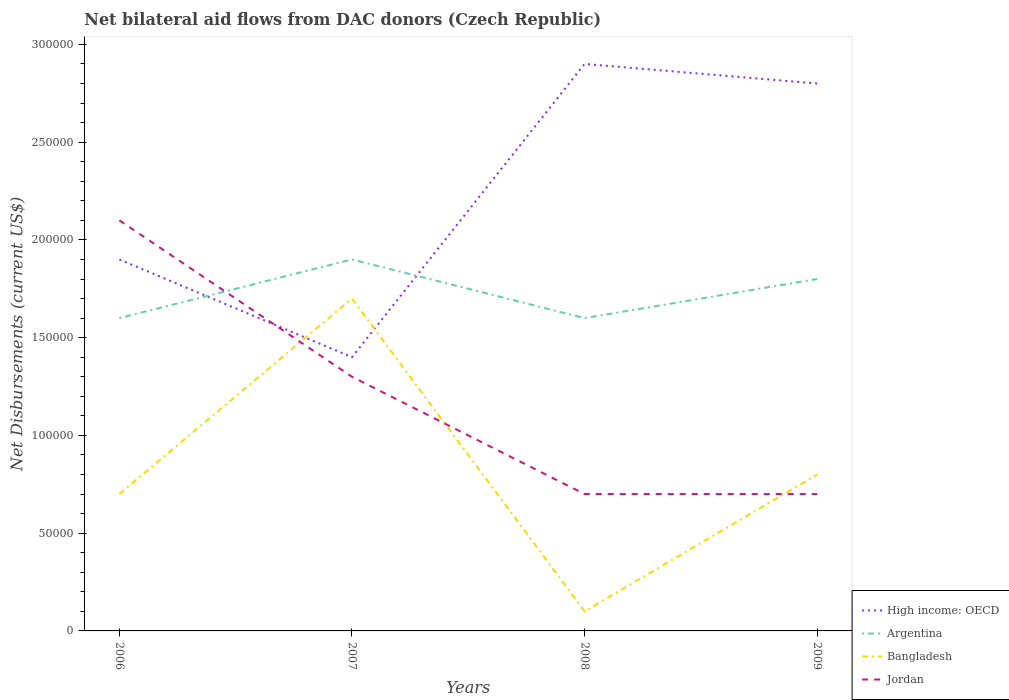How many different coloured lines are there?
Make the answer very short. 4. Does the line corresponding to Jordan intersect with the line corresponding to Bangladesh?
Provide a succinct answer. Yes. Across all years, what is the maximum net bilateral aid flows in Bangladesh?
Provide a short and direct response. 10000. In which year was the net bilateral aid flows in Bangladesh maximum?
Your answer should be compact. 2008. What is the total net bilateral aid flows in Argentina in the graph?
Your answer should be very brief. -2.00e+04. What is the difference between the highest and the second highest net bilateral aid flows in Jordan?
Offer a very short reply. 1.40e+05. What is the difference between the highest and the lowest net bilateral aid flows in Argentina?
Offer a very short reply. 2. Is the net bilateral aid flows in Argentina strictly greater than the net bilateral aid flows in High income: OECD over the years?
Provide a succinct answer. No. How many lines are there?
Give a very brief answer. 4. How many years are there in the graph?
Provide a short and direct response. 4. Are the values on the major ticks of Y-axis written in scientific E-notation?
Ensure brevity in your answer.  No. Where does the legend appear in the graph?
Offer a very short reply. Bottom right. How are the legend labels stacked?
Make the answer very short. Vertical. What is the title of the graph?
Provide a succinct answer. Net bilateral aid flows from DAC donors (Czech Republic). What is the label or title of the Y-axis?
Make the answer very short. Net Disbursements (current US$). What is the Net Disbursements (current US$) in Bangladesh in 2006?
Ensure brevity in your answer.  7.00e+04. What is the Net Disbursements (current US$) of Argentina in 2007?
Your answer should be very brief. 1.90e+05. What is the Net Disbursements (current US$) in Jordan in 2007?
Your response must be concise. 1.30e+05. What is the Net Disbursements (current US$) in High income: OECD in 2008?
Provide a short and direct response. 2.90e+05. What is the Net Disbursements (current US$) of Jordan in 2008?
Provide a succinct answer. 7.00e+04. What is the Net Disbursements (current US$) in High income: OECD in 2009?
Provide a short and direct response. 2.80e+05. What is the Net Disbursements (current US$) in Argentina in 2009?
Your response must be concise. 1.80e+05. What is the Net Disbursements (current US$) in Bangladesh in 2009?
Offer a terse response. 8.00e+04. Across all years, what is the maximum Net Disbursements (current US$) of High income: OECD?
Offer a very short reply. 2.90e+05. Across all years, what is the maximum Net Disbursements (current US$) of Argentina?
Give a very brief answer. 1.90e+05. Across all years, what is the maximum Net Disbursements (current US$) in Jordan?
Provide a short and direct response. 2.10e+05. Across all years, what is the minimum Net Disbursements (current US$) of High income: OECD?
Your response must be concise. 1.40e+05. What is the total Net Disbursements (current US$) of Argentina in the graph?
Give a very brief answer. 6.90e+05. What is the difference between the Net Disbursements (current US$) of High income: OECD in 2006 and that in 2007?
Provide a short and direct response. 5.00e+04. What is the difference between the Net Disbursements (current US$) of Argentina in 2006 and that in 2007?
Ensure brevity in your answer.  -3.00e+04. What is the difference between the Net Disbursements (current US$) of Jordan in 2006 and that in 2007?
Keep it short and to the point. 8.00e+04. What is the difference between the Net Disbursements (current US$) of Argentina in 2006 and that in 2008?
Your response must be concise. 0. What is the difference between the Net Disbursements (current US$) in Bangladesh in 2006 and that in 2008?
Give a very brief answer. 6.00e+04. What is the difference between the Net Disbursements (current US$) of Jordan in 2006 and that in 2008?
Offer a very short reply. 1.40e+05. What is the difference between the Net Disbursements (current US$) of Argentina in 2006 and that in 2009?
Offer a very short reply. -2.00e+04. What is the difference between the Net Disbursements (current US$) in Bangladesh in 2006 and that in 2009?
Provide a short and direct response. -10000. What is the difference between the Net Disbursements (current US$) of Jordan in 2006 and that in 2009?
Offer a terse response. 1.40e+05. What is the difference between the Net Disbursements (current US$) of Bangladesh in 2007 and that in 2008?
Give a very brief answer. 1.60e+05. What is the difference between the Net Disbursements (current US$) of Argentina in 2007 and that in 2009?
Your response must be concise. 10000. What is the difference between the Net Disbursements (current US$) in Bangladesh in 2007 and that in 2009?
Make the answer very short. 9.00e+04. What is the difference between the Net Disbursements (current US$) in Jordan in 2007 and that in 2009?
Your answer should be compact. 6.00e+04. What is the difference between the Net Disbursements (current US$) of High income: OECD in 2008 and that in 2009?
Make the answer very short. 10000. What is the difference between the Net Disbursements (current US$) in Argentina in 2008 and that in 2009?
Provide a succinct answer. -2.00e+04. What is the difference between the Net Disbursements (current US$) of Bangladesh in 2008 and that in 2009?
Ensure brevity in your answer.  -7.00e+04. What is the difference between the Net Disbursements (current US$) of High income: OECD in 2006 and the Net Disbursements (current US$) of Bangladesh in 2007?
Your answer should be very brief. 2.00e+04. What is the difference between the Net Disbursements (current US$) in High income: OECD in 2006 and the Net Disbursements (current US$) in Jordan in 2007?
Ensure brevity in your answer.  6.00e+04. What is the difference between the Net Disbursements (current US$) of Argentina in 2006 and the Net Disbursements (current US$) of Bangladesh in 2007?
Offer a very short reply. -10000. What is the difference between the Net Disbursements (current US$) of High income: OECD in 2006 and the Net Disbursements (current US$) of Bangladesh in 2008?
Your answer should be very brief. 1.80e+05. What is the difference between the Net Disbursements (current US$) of Argentina in 2006 and the Net Disbursements (current US$) of Bangladesh in 2008?
Ensure brevity in your answer.  1.50e+05. What is the difference between the Net Disbursements (current US$) in Argentina in 2006 and the Net Disbursements (current US$) in Jordan in 2008?
Offer a terse response. 9.00e+04. What is the difference between the Net Disbursements (current US$) in High income: OECD in 2006 and the Net Disbursements (current US$) in Bangladesh in 2009?
Provide a short and direct response. 1.10e+05. What is the difference between the Net Disbursements (current US$) in High income: OECD in 2006 and the Net Disbursements (current US$) in Jordan in 2009?
Your response must be concise. 1.20e+05. What is the difference between the Net Disbursements (current US$) in High income: OECD in 2007 and the Net Disbursements (current US$) in Bangladesh in 2008?
Your answer should be compact. 1.30e+05. What is the difference between the Net Disbursements (current US$) in High income: OECD in 2007 and the Net Disbursements (current US$) in Jordan in 2008?
Give a very brief answer. 7.00e+04. What is the difference between the Net Disbursements (current US$) in High income: OECD in 2007 and the Net Disbursements (current US$) in Jordan in 2009?
Your response must be concise. 7.00e+04. What is the difference between the Net Disbursements (current US$) in Argentina in 2007 and the Net Disbursements (current US$) in Bangladesh in 2009?
Your answer should be very brief. 1.10e+05. What is the difference between the Net Disbursements (current US$) of Bangladesh in 2007 and the Net Disbursements (current US$) of Jordan in 2009?
Your answer should be very brief. 1.00e+05. What is the difference between the Net Disbursements (current US$) of High income: OECD in 2008 and the Net Disbursements (current US$) of Argentina in 2009?
Your answer should be compact. 1.10e+05. What is the average Net Disbursements (current US$) in High income: OECD per year?
Your answer should be very brief. 2.25e+05. What is the average Net Disbursements (current US$) of Argentina per year?
Offer a terse response. 1.72e+05. What is the average Net Disbursements (current US$) of Bangladesh per year?
Your response must be concise. 8.25e+04. In the year 2006, what is the difference between the Net Disbursements (current US$) in High income: OECD and Net Disbursements (current US$) in Jordan?
Offer a terse response. -2.00e+04. In the year 2006, what is the difference between the Net Disbursements (current US$) of Argentina and Net Disbursements (current US$) of Jordan?
Make the answer very short. -5.00e+04. In the year 2006, what is the difference between the Net Disbursements (current US$) of Bangladesh and Net Disbursements (current US$) of Jordan?
Your answer should be very brief. -1.40e+05. In the year 2007, what is the difference between the Net Disbursements (current US$) in High income: OECD and Net Disbursements (current US$) in Argentina?
Your answer should be compact. -5.00e+04. In the year 2007, what is the difference between the Net Disbursements (current US$) in High income: OECD and Net Disbursements (current US$) in Jordan?
Keep it short and to the point. 10000. In the year 2007, what is the difference between the Net Disbursements (current US$) in Argentina and Net Disbursements (current US$) in Jordan?
Your answer should be very brief. 6.00e+04. In the year 2007, what is the difference between the Net Disbursements (current US$) in Bangladesh and Net Disbursements (current US$) in Jordan?
Keep it short and to the point. 4.00e+04. In the year 2008, what is the difference between the Net Disbursements (current US$) in High income: OECD and Net Disbursements (current US$) in Argentina?
Your answer should be compact. 1.30e+05. In the year 2008, what is the difference between the Net Disbursements (current US$) of Argentina and Net Disbursements (current US$) of Jordan?
Your response must be concise. 9.00e+04. In the year 2009, what is the difference between the Net Disbursements (current US$) in High income: OECD and Net Disbursements (current US$) in Jordan?
Provide a succinct answer. 2.10e+05. In the year 2009, what is the difference between the Net Disbursements (current US$) in Argentina and Net Disbursements (current US$) in Jordan?
Offer a very short reply. 1.10e+05. What is the ratio of the Net Disbursements (current US$) of High income: OECD in 2006 to that in 2007?
Your answer should be compact. 1.36. What is the ratio of the Net Disbursements (current US$) in Argentina in 2006 to that in 2007?
Ensure brevity in your answer.  0.84. What is the ratio of the Net Disbursements (current US$) of Bangladesh in 2006 to that in 2007?
Your answer should be very brief. 0.41. What is the ratio of the Net Disbursements (current US$) in Jordan in 2006 to that in 2007?
Provide a short and direct response. 1.62. What is the ratio of the Net Disbursements (current US$) of High income: OECD in 2006 to that in 2008?
Your response must be concise. 0.66. What is the ratio of the Net Disbursements (current US$) in Bangladesh in 2006 to that in 2008?
Offer a terse response. 7. What is the ratio of the Net Disbursements (current US$) of High income: OECD in 2006 to that in 2009?
Keep it short and to the point. 0.68. What is the ratio of the Net Disbursements (current US$) in Bangladesh in 2006 to that in 2009?
Ensure brevity in your answer.  0.88. What is the ratio of the Net Disbursements (current US$) of Jordan in 2006 to that in 2009?
Provide a short and direct response. 3. What is the ratio of the Net Disbursements (current US$) of High income: OECD in 2007 to that in 2008?
Your response must be concise. 0.48. What is the ratio of the Net Disbursements (current US$) of Argentina in 2007 to that in 2008?
Provide a short and direct response. 1.19. What is the ratio of the Net Disbursements (current US$) in Bangladesh in 2007 to that in 2008?
Make the answer very short. 17. What is the ratio of the Net Disbursements (current US$) of Jordan in 2007 to that in 2008?
Ensure brevity in your answer.  1.86. What is the ratio of the Net Disbursements (current US$) in High income: OECD in 2007 to that in 2009?
Give a very brief answer. 0.5. What is the ratio of the Net Disbursements (current US$) in Argentina in 2007 to that in 2009?
Provide a short and direct response. 1.06. What is the ratio of the Net Disbursements (current US$) in Bangladesh in 2007 to that in 2009?
Provide a succinct answer. 2.12. What is the ratio of the Net Disbursements (current US$) of Jordan in 2007 to that in 2009?
Offer a terse response. 1.86. What is the ratio of the Net Disbursements (current US$) in High income: OECD in 2008 to that in 2009?
Provide a short and direct response. 1.04. What is the difference between the highest and the second highest Net Disbursements (current US$) of High income: OECD?
Offer a terse response. 10000. What is the difference between the highest and the second highest Net Disbursements (current US$) in Argentina?
Ensure brevity in your answer.  10000. What is the difference between the highest and the second highest Net Disbursements (current US$) of Bangladesh?
Your response must be concise. 9.00e+04. What is the difference between the highest and the lowest Net Disbursements (current US$) in Argentina?
Keep it short and to the point. 3.00e+04. What is the difference between the highest and the lowest Net Disbursements (current US$) in Jordan?
Offer a very short reply. 1.40e+05. 